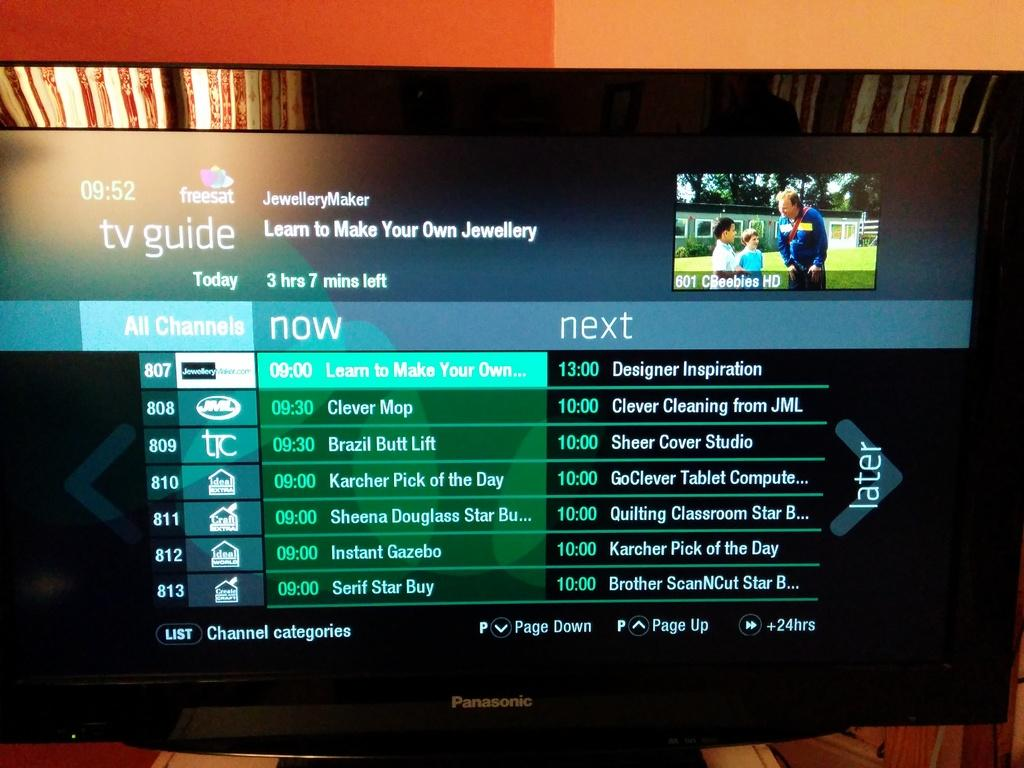<image>
Write a terse but informative summary of the picture. A Panasonic TV has the tv guide channel displayed. 